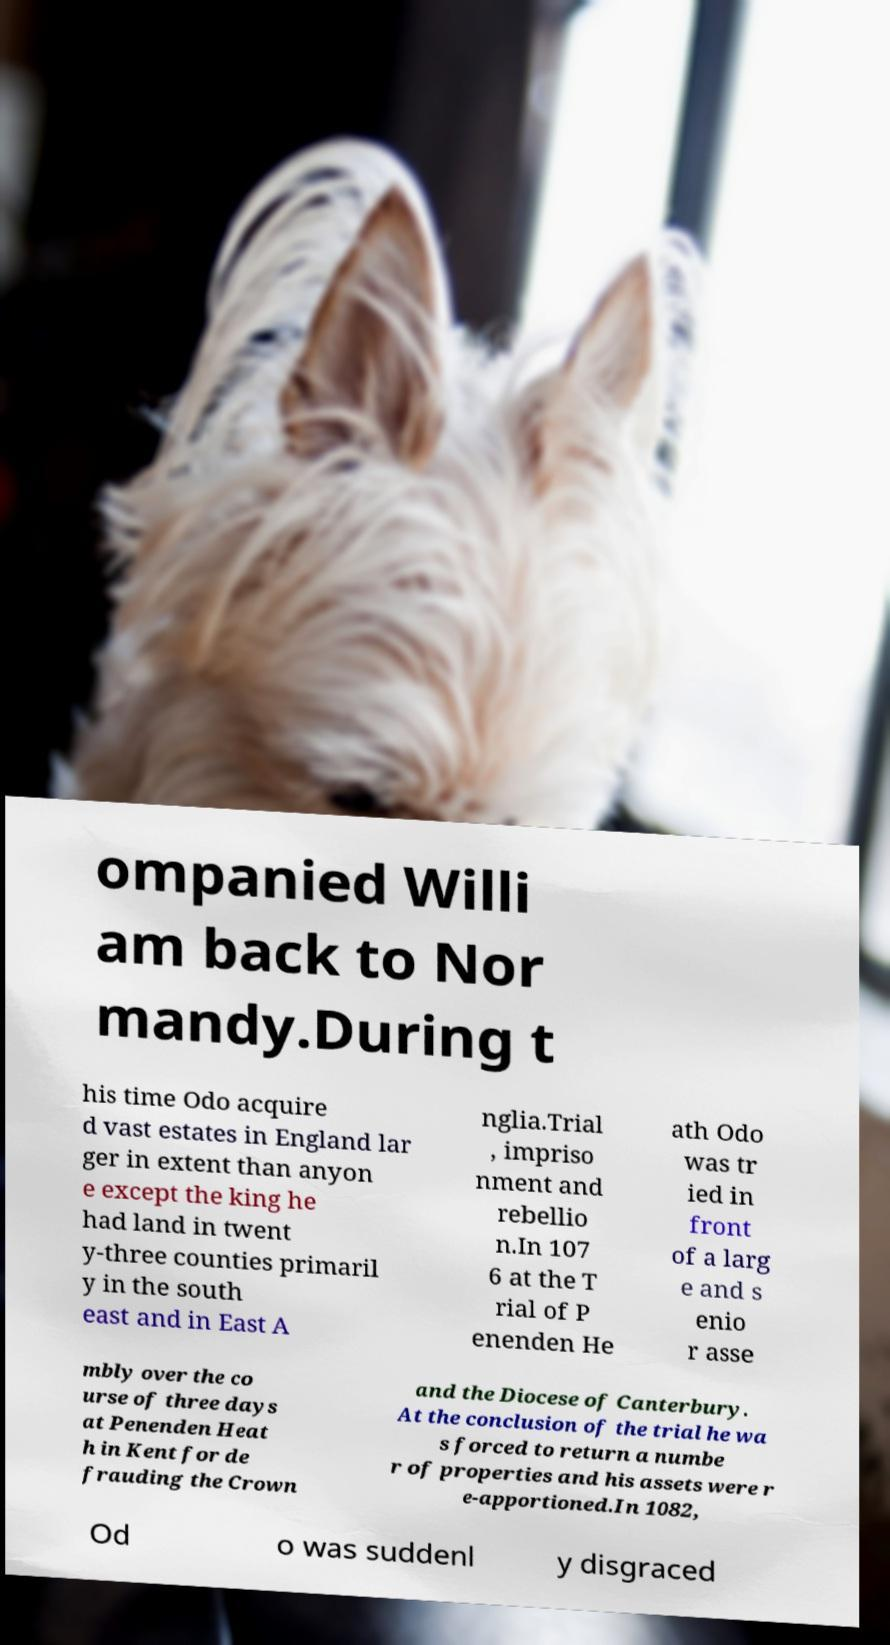What messages or text are displayed in this image? I need them in a readable, typed format. ompanied Willi am back to Nor mandy.During t his time Odo acquire d vast estates in England lar ger in extent than anyon e except the king he had land in twent y-three counties primaril y in the south east and in East A nglia.Trial , impriso nment and rebellio n.In 107 6 at the T rial of P enenden He ath Odo was tr ied in front of a larg e and s enio r asse mbly over the co urse of three days at Penenden Heat h in Kent for de frauding the Crown and the Diocese of Canterbury. At the conclusion of the trial he wa s forced to return a numbe r of properties and his assets were r e-apportioned.In 1082, Od o was suddenl y disgraced 